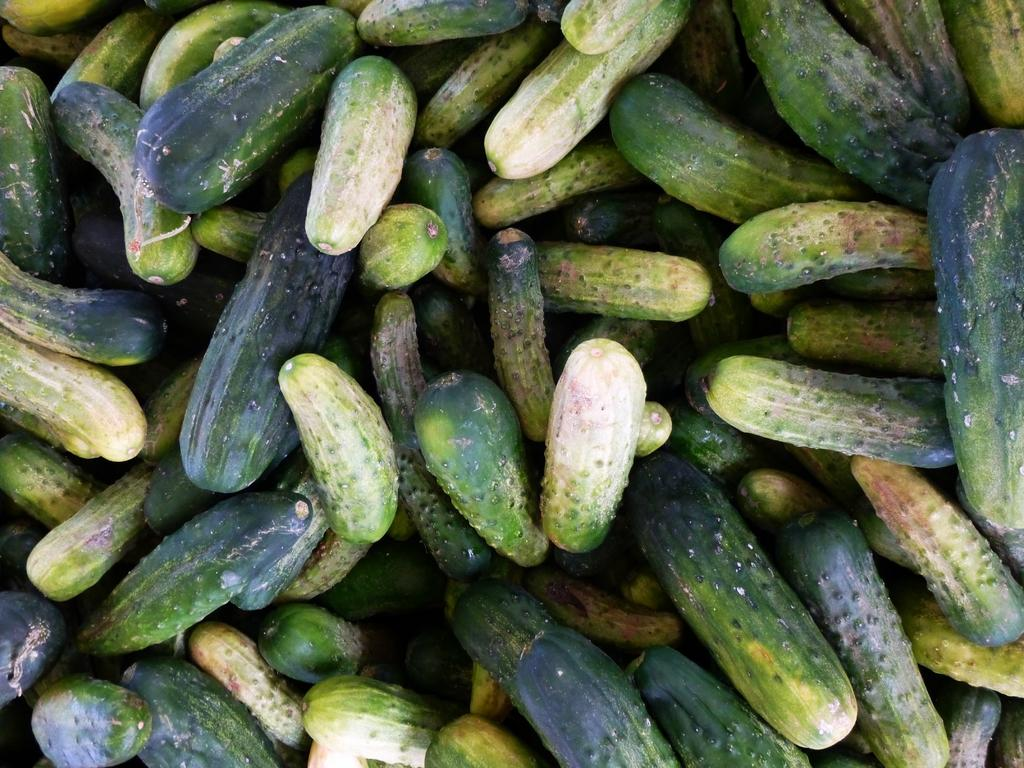What type of vegetable is present in the image? The image contains cucumbers. How many boats are visible in the image? There are no boats present in the image; it only contains cucumbers. 